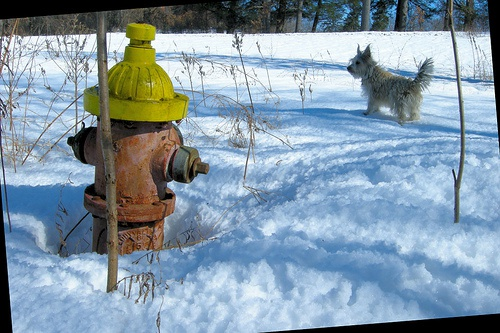Describe the objects in this image and their specific colors. I can see fire hydrant in black, olive, and maroon tones and dog in black, gray, purple, and darkgray tones in this image. 